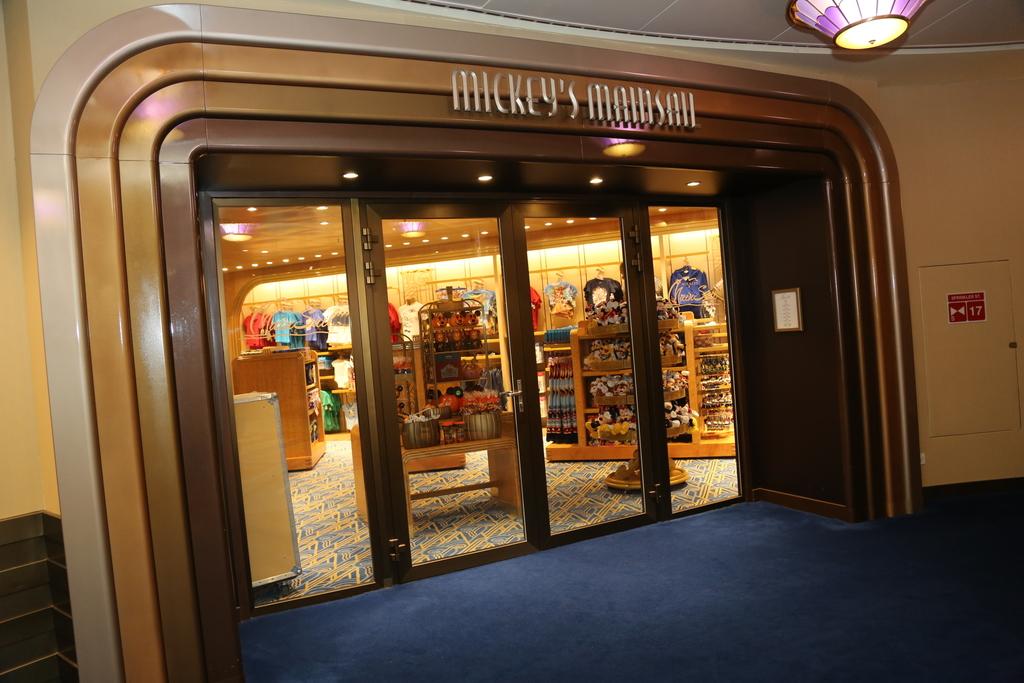What is the shop name?
Provide a short and direct response. Mickey's mainsail. What shop is this?q?
Ensure brevity in your answer.  Mickey's mainsail. 